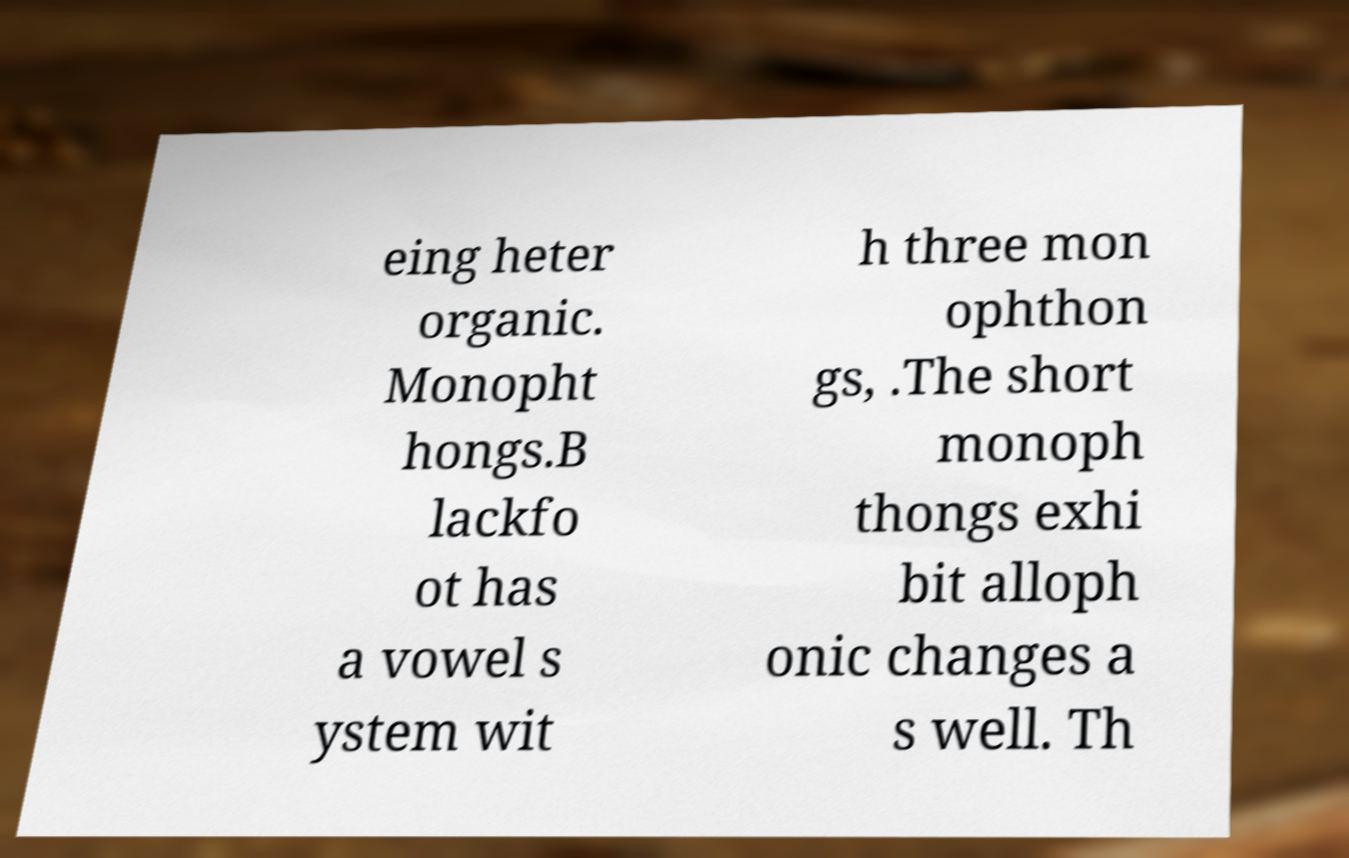I need the written content from this picture converted into text. Can you do that? eing heter organic. Monopht hongs.B lackfo ot has a vowel s ystem wit h three mon ophthon gs, .The short monoph thongs exhi bit alloph onic changes a s well. Th 